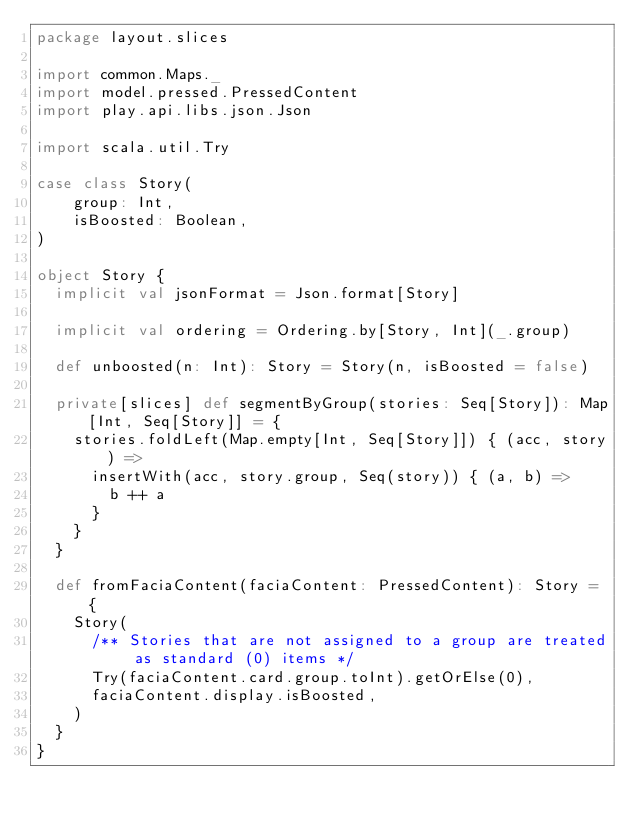<code> <loc_0><loc_0><loc_500><loc_500><_Scala_>package layout.slices

import common.Maps._
import model.pressed.PressedContent
import play.api.libs.json.Json

import scala.util.Try

case class Story(
    group: Int,
    isBoosted: Boolean,
)

object Story {
  implicit val jsonFormat = Json.format[Story]

  implicit val ordering = Ordering.by[Story, Int](_.group)

  def unboosted(n: Int): Story = Story(n, isBoosted = false)

  private[slices] def segmentByGroup(stories: Seq[Story]): Map[Int, Seq[Story]] = {
    stories.foldLeft(Map.empty[Int, Seq[Story]]) { (acc, story) =>
      insertWith(acc, story.group, Seq(story)) { (a, b) =>
        b ++ a
      }
    }
  }

  def fromFaciaContent(faciaContent: PressedContent): Story = {
    Story(
      /** Stories that are not assigned to a group are treated as standard (0) items */
      Try(faciaContent.card.group.toInt).getOrElse(0),
      faciaContent.display.isBoosted,
    )
  }
}
</code> 